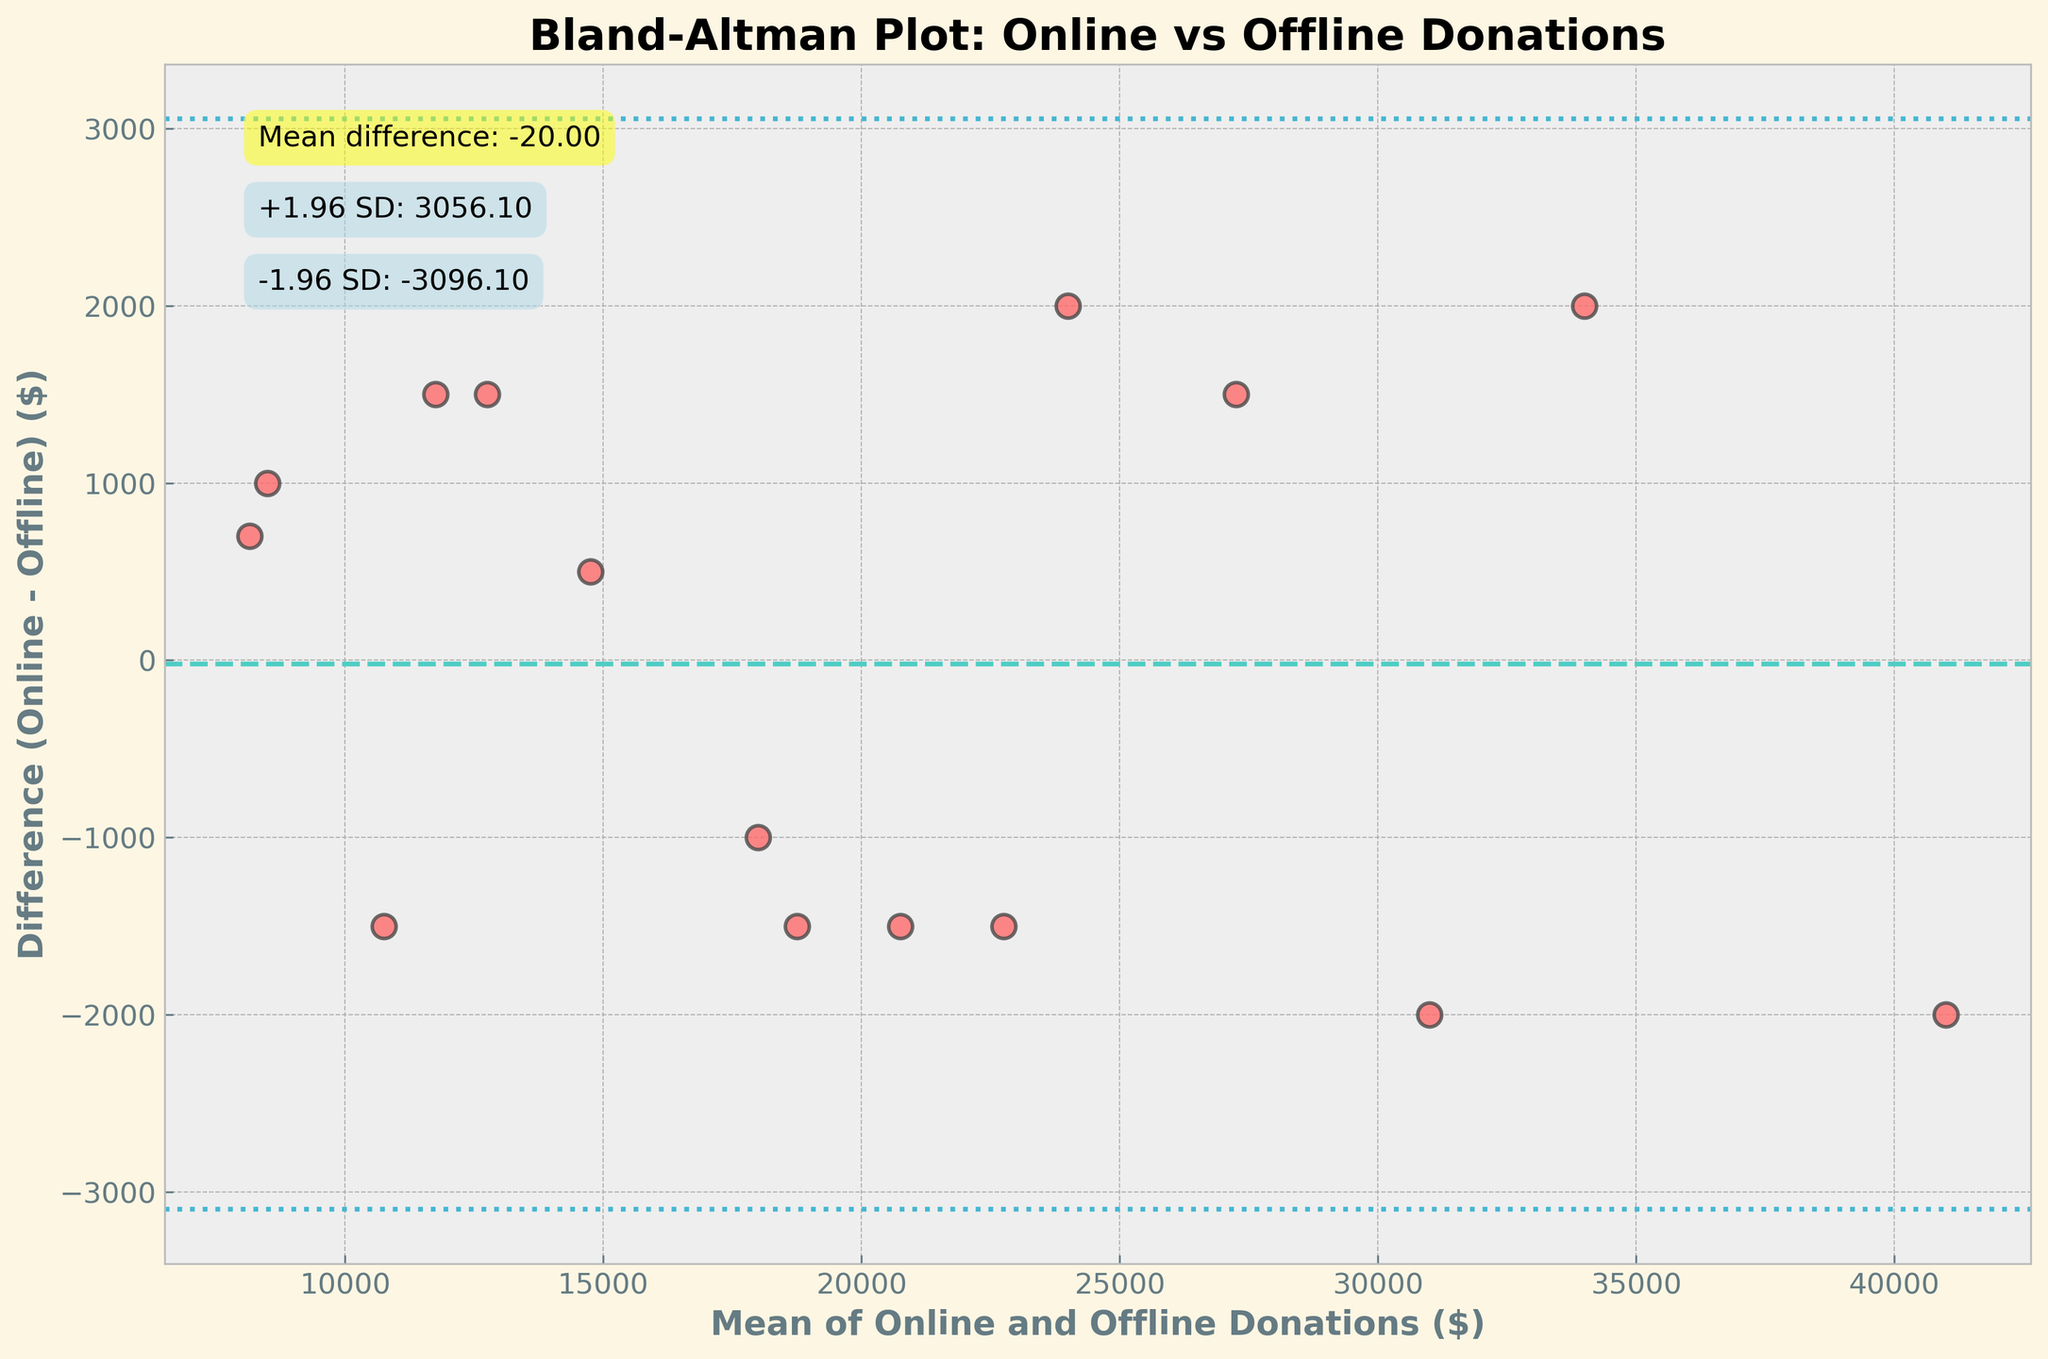What is the title of the plot? The title of the plot is located at the top of the figure and it gives an idea of what the plot is about.
Answer: Bland-Altman Plot: Online vs Offline Donations What is the mean difference between online and offline donations? The mean difference is indicated by the horizontal dashed line and the annotation on the plot. This value represents the average difference between online and offline donations.
Answer: 366.67 What is the range for the limits of agreement? The limits of agreement are shown by the dotted lines above and below the mean difference line and are also annotated on the plot. These limits indicate the range within which 95% of the differences between the measurements lie.
Answer: 3574.22 and -2840.88 How many data points are there in the plot? Each data point is represented by a scatter plot dot. By counting these dots, you can determine the total number of data points.
Answer: 15 What does each point on the plot represent? Each point represents a pair of online and offline donation amounts, plotted against their mean and difference.
Answer: A pair of online and offline donations Are there more points above or below the mean difference line? By visually inspecting the plot, you can count the points above and below the mean difference line to determine which are more.
Answer: Below Which data point shows the largest difference between online and offline donations? The largest difference is the point farthest from the mean difference line.
Answer: Around a mean of 14,250 with a difference of 1,500 What color is used for the scatter points on the plot? The points on the scatter plot are colored in a specific way for clarity and distinction.
Answer: Red What is the average value of the offline donations for the plotted data points? To find this value, sum all the offline donations and divide by the number of data points. This requires precise calculations.
Answer: 20720 How does the standard deviation of the differences reflect on the plot? The spread of the data points around the mean difference line provides insight into the consistency of the differences; wider spread indicates larger standard deviation.
Answer: It shows the limits of agreement at ±1.96 standard deviations from the mean difference 